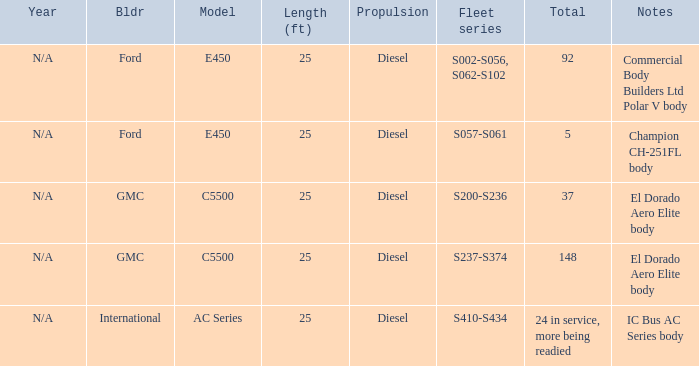Which model with a fleet series of s410-s434? AC Series. 